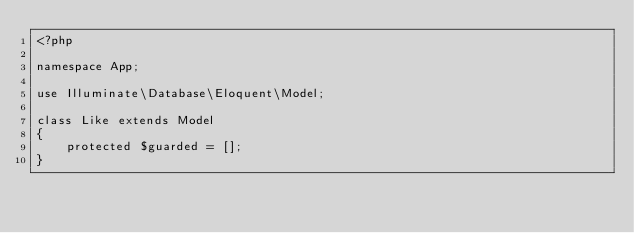Convert code to text. <code><loc_0><loc_0><loc_500><loc_500><_PHP_><?php

namespace App;

use Illuminate\Database\Eloquent\Model;

class Like extends Model
{
    protected $guarded = [];
}</code> 